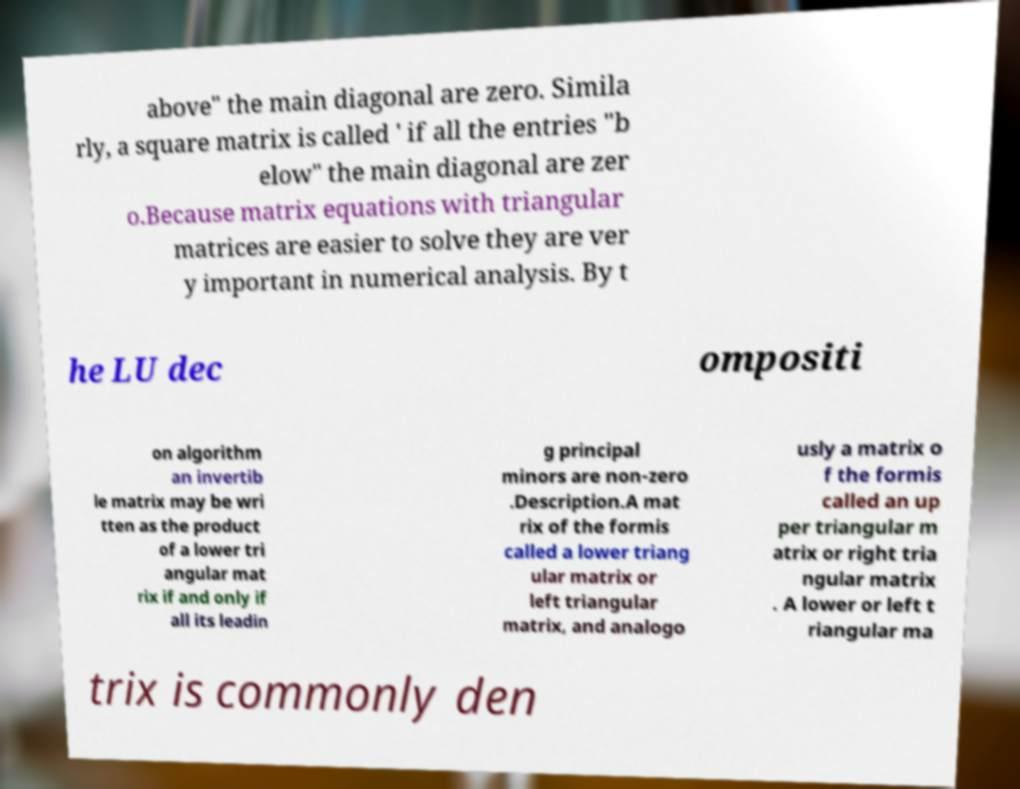Can you read and provide the text displayed in the image?This photo seems to have some interesting text. Can you extract and type it out for me? above" the main diagonal are zero. Simila rly, a square matrix is called ' if all the entries "b elow" the main diagonal are zer o.Because matrix equations with triangular matrices are easier to solve they are ver y important in numerical analysis. By t he LU dec ompositi on algorithm an invertib le matrix may be wri tten as the product of a lower tri angular mat rix if and only if all its leadin g principal minors are non-zero .Description.A mat rix of the formis called a lower triang ular matrix or left triangular matrix, and analogo usly a matrix o f the formis called an up per triangular m atrix or right tria ngular matrix . A lower or left t riangular ma trix is commonly den 